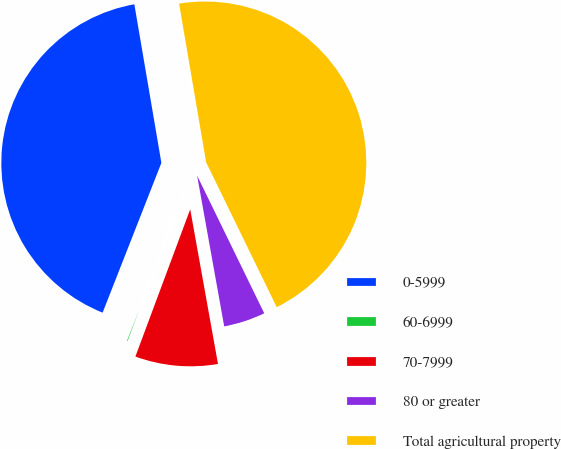Convert chart. <chart><loc_0><loc_0><loc_500><loc_500><pie_chart><fcel>0-5999<fcel>60-6999<fcel>70-7999<fcel>80 or greater<fcel>Total agricultural property<nl><fcel>41.36%<fcel>0.28%<fcel>8.5%<fcel>4.39%<fcel>45.47%<nl></chart> 